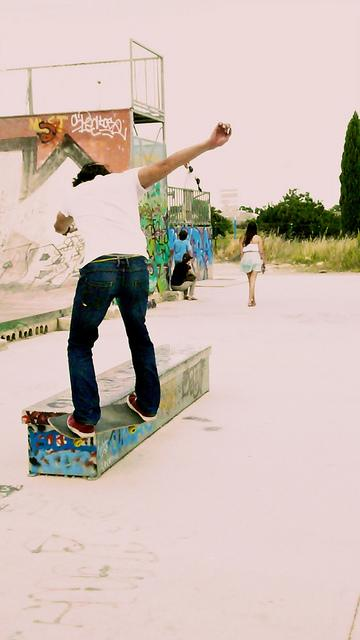Why si the board hanging from the box?

Choices:
A) is stuck
B) bounced there
C) showing off
D) fell there showing off 